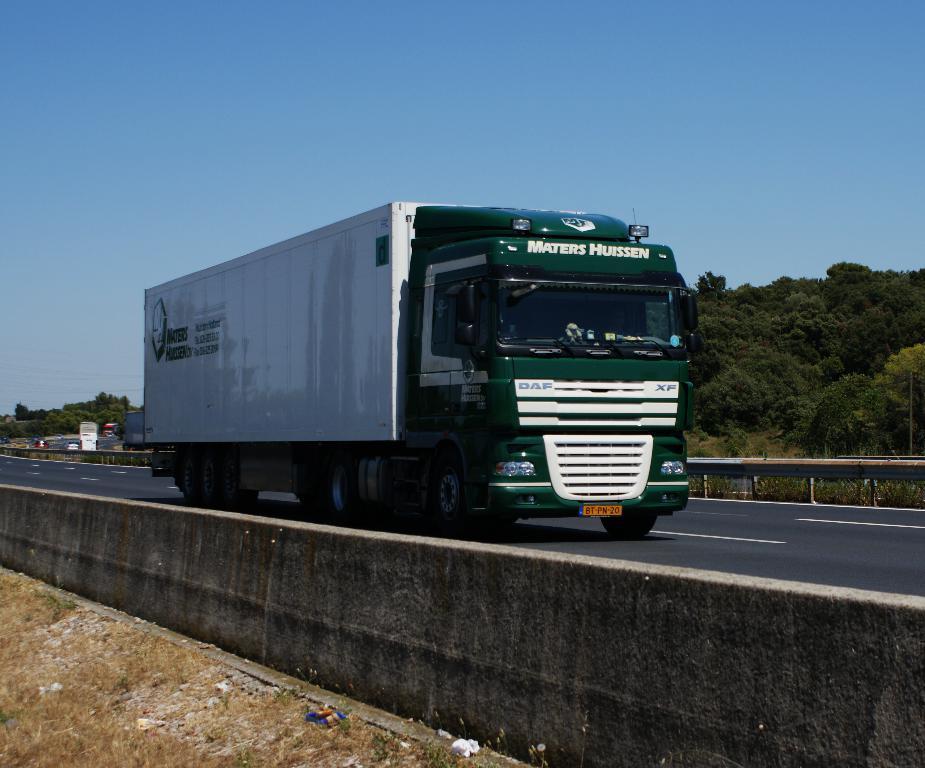Describe this image in one or two sentences. In the image there is a vehicle on the road and behind the vehicle there are many trees. 